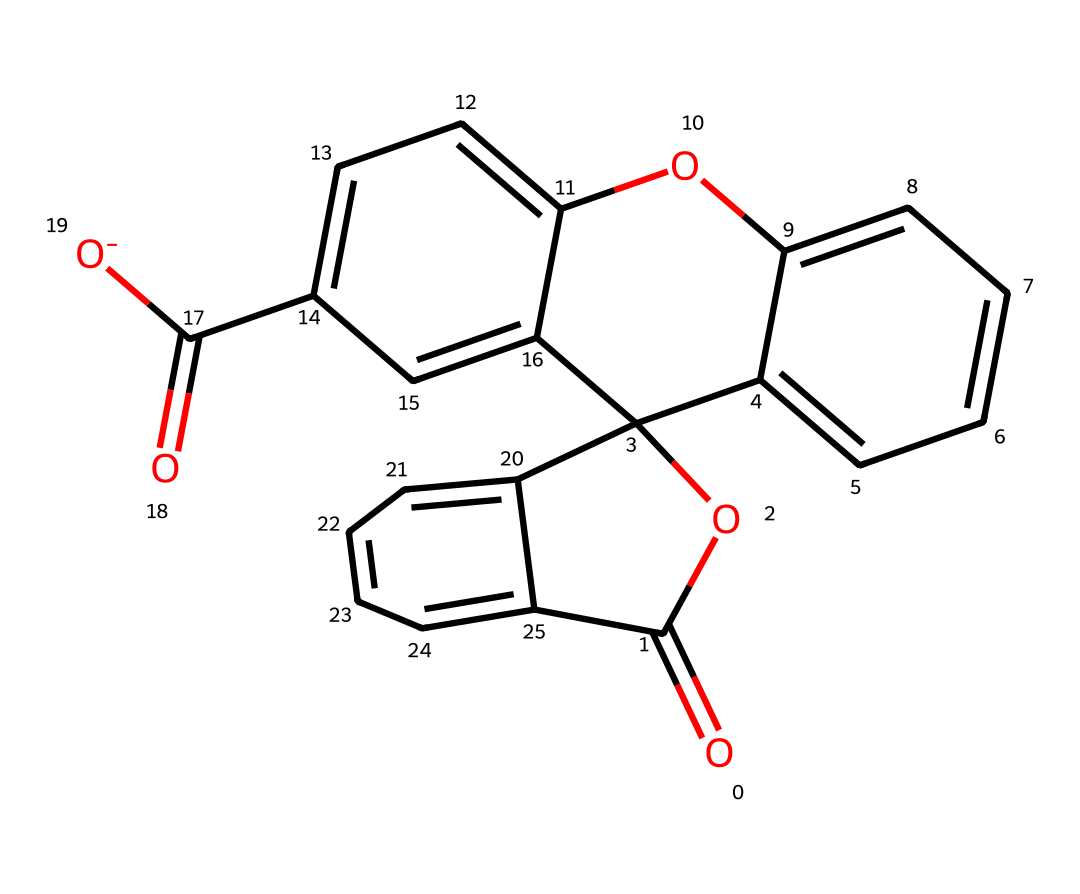What type of functional groups are present in this molecule? The structure contains carbonyl (C=O) and ether (C-O-C) groups. Carbonyls are indicated by the presence of C=O bonds, while ethers can be identified by the C-O-C connectivity.
Answer: carbonyl and ether How many aromatic rings are in the structure? The molecule features three distinct aromatic rings, identifiable by the alternating double bonds in their cyclic structure.
Answer: three What is the molecular weight of this compound? To determine the molecular weight, we count all the various atoms present in the structure: 21 carbon atoms, 16 hydrogen atoms, 5 oxygen atoms, giving us a total molecular weight of 336.34 g/mol.
Answer: 336.34 Which atom is potentially ionizable in this molecule? The structure has a carboxylate group (C(=O)[O-]), wherein the oxygen atom bearing the negative charge (O-) indicates potential ionization behavior typical of acids.
Answer: oxygen Does this molecule exhibit any symmetry? Visual inspection of the structure reveals that the molecule has a symmetrical arrangement of its aromatic rings, indicating a degree of symmetry in its overall geometry.
Answer: symmetry Is there a specific application of this molecule in bioimaging? This compound, known as a fluorescent probe, can be utilized in bioimaging due to its ability to fluoresce under specific light conditions, aiding in visualization of biological processes.
Answer: fluorescent probe 